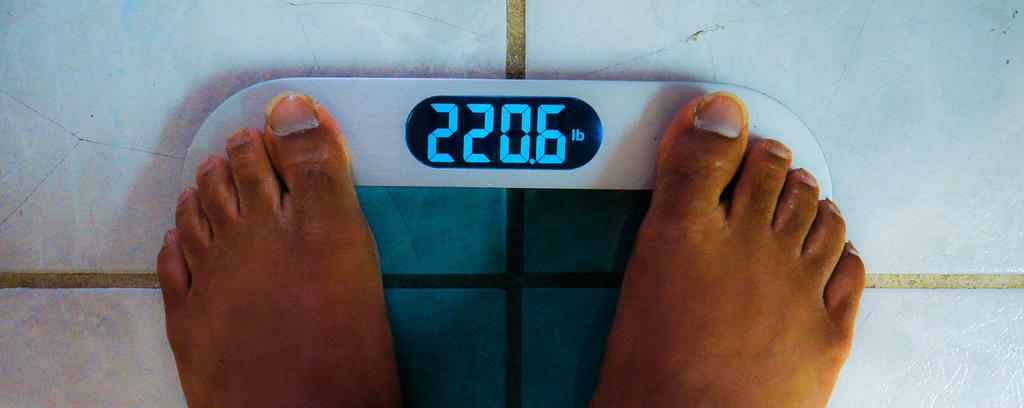What is the person in the image doing? The person in the image is using a weight machine. Which part of the person's body can be seen in the image? The person's legs are visible in the image. What color is the background of the image? The background of the image is white. What type of book is the person reading while using the weight machine in the image? There is no book or reading activity present in the image; the person is using a weight machine. 